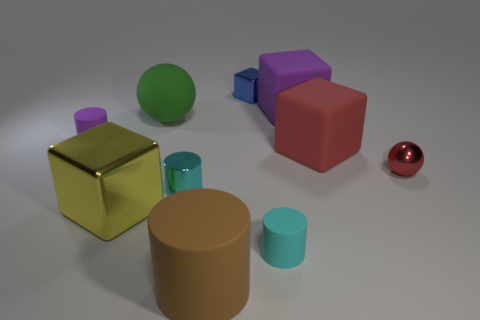Is there a yellow metallic object that has the same size as the brown matte object? Yes, there is a yellow metallic cube that appears to be approximately the same size as the brown matte cylinder. 